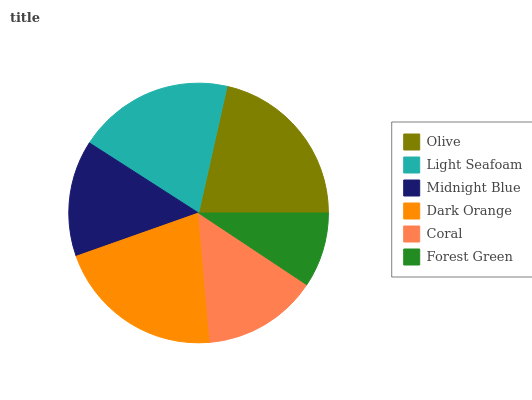Is Forest Green the minimum?
Answer yes or no. Yes. Is Olive the maximum?
Answer yes or no. Yes. Is Light Seafoam the minimum?
Answer yes or no. No. Is Light Seafoam the maximum?
Answer yes or no. No. Is Olive greater than Light Seafoam?
Answer yes or no. Yes. Is Light Seafoam less than Olive?
Answer yes or no. Yes. Is Light Seafoam greater than Olive?
Answer yes or no. No. Is Olive less than Light Seafoam?
Answer yes or no. No. Is Light Seafoam the high median?
Answer yes or no. Yes. Is Midnight Blue the low median?
Answer yes or no. Yes. Is Forest Green the high median?
Answer yes or no. No. Is Coral the low median?
Answer yes or no. No. 